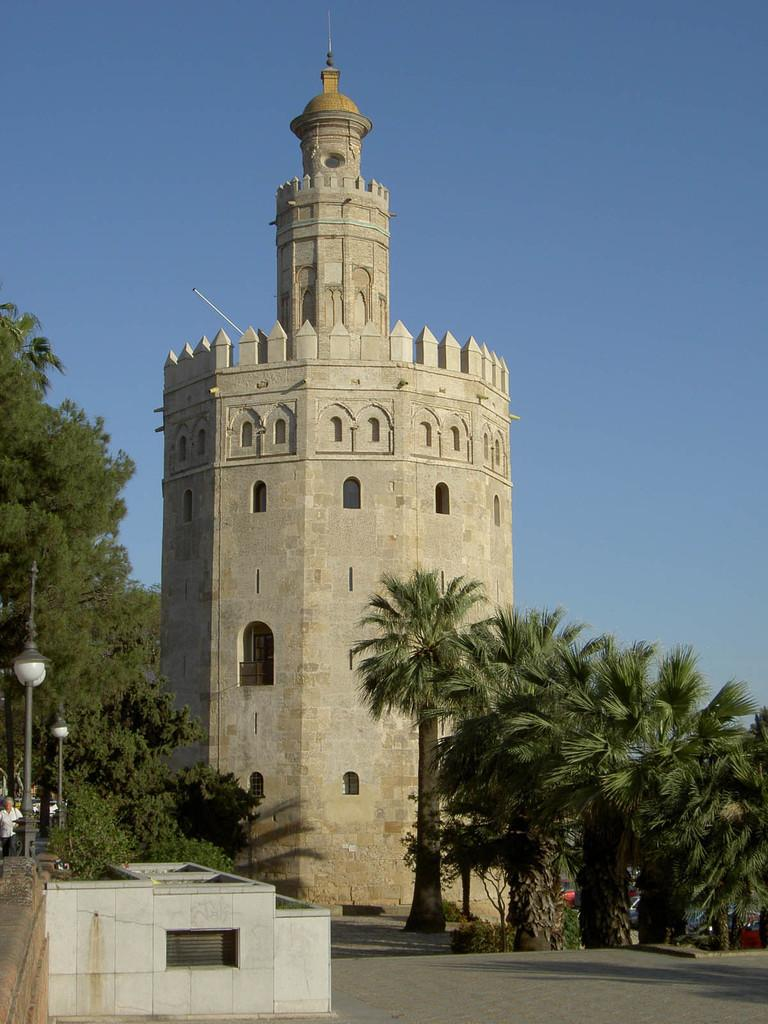What is the main structure in the image? There is a monument in the image. What type of vegetation is present in the image? There are trees in the image. What type of lighting is present in the image? There are pole lights in the image. What is the man in the image doing? A man is walking in the image. What type of vehicles are parked in the image? There are parked cars in the image. What is the color of the sky in the image? The sky is blue in the image. What type of pickle is being sold at the monument in the image? There is no pickle or any indication of a sale in the image; it features a monument, trees, pole lights, a man walking, parked cars, and a blue sky. 